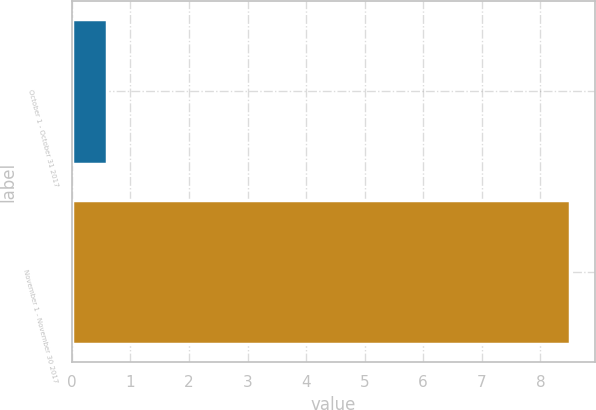<chart> <loc_0><loc_0><loc_500><loc_500><bar_chart><fcel>October 1 - October 31 2017<fcel>November 1 - November 30 2017<nl><fcel>0.6<fcel>8.5<nl></chart> 